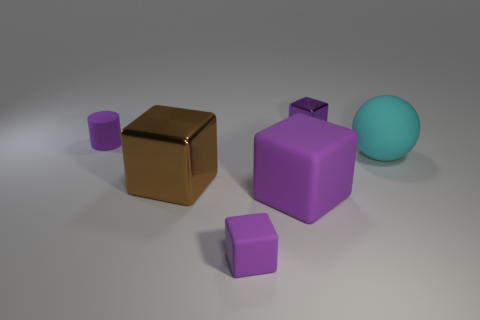How many purple cubes must be subtracted to get 2 purple cubes? 1 Subtract all green spheres. How many purple cubes are left? 3 Subtract 1 cubes. How many cubes are left? 3 Add 4 tiny rubber cylinders. How many objects exist? 10 Subtract all balls. How many objects are left? 5 Add 1 big purple blocks. How many big purple blocks exist? 2 Subtract 0 green cylinders. How many objects are left? 6 Subtract all small purple rubber things. Subtract all large purple blocks. How many objects are left? 3 Add 3 large brown cubes. How many large brown cubes are left? 4 